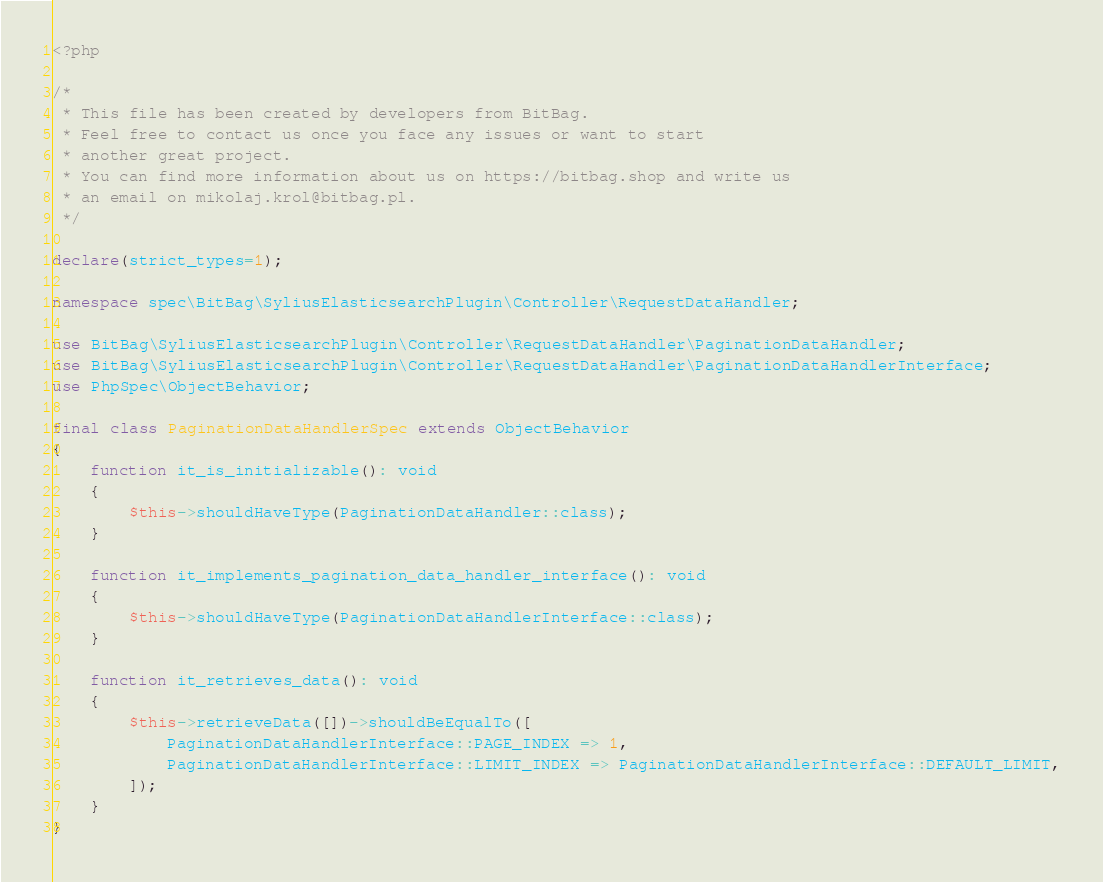<code> <loc_0><loc_0><loc_500><loc_500><_PHP_><?php

/*
 * This file has been created by developers from BitBag.
 * Feel free to contact us once you face any issues or want to start
 * another great project.
 * You can find more information about us on https://bitbag.shop and write us
 * an email on mikolaj.krol@bitbag.pl.
 */

declare(strict_types=1);

namespace spec\BitBag\SyliusElasticsearchPlugin\Controller\RequestDataHandler;

use BitBag\SyliusElasticsearchPlugin\Controller\RequestDataHandler\PaginationDataHandler;
use BitBag\SyliusElasticsearchPlugin\Controller\RequestDataHandler\PaginationDataHandlerInterface;
use PhpSpec\ObjectBehavior;

final class PaginationDataHandlerSpec extends ObjectBehavior
{
    function it_is_initializable(): void
    {
        $this->shouldHaveType(PaginationDataHandler::class);
    }

    function it_implements_pagination_data_handler_interface(): void
    {
        $this->shouldHaveType(PaginationDataHandlerInterface::class);
    }

    function it_retrieves_data(): void
    {
        $this->retrieveData([])->shouldBeEqualTo([
            PaginationDataHandlerInterface::PAGE_INDEX => 1,
            PaginationDataHandlerInterface::LIMIT_INDEX => PaginationDataHandlerInterface::DEFAULT_LIMIT,
        ]);
    }
}
</code> 